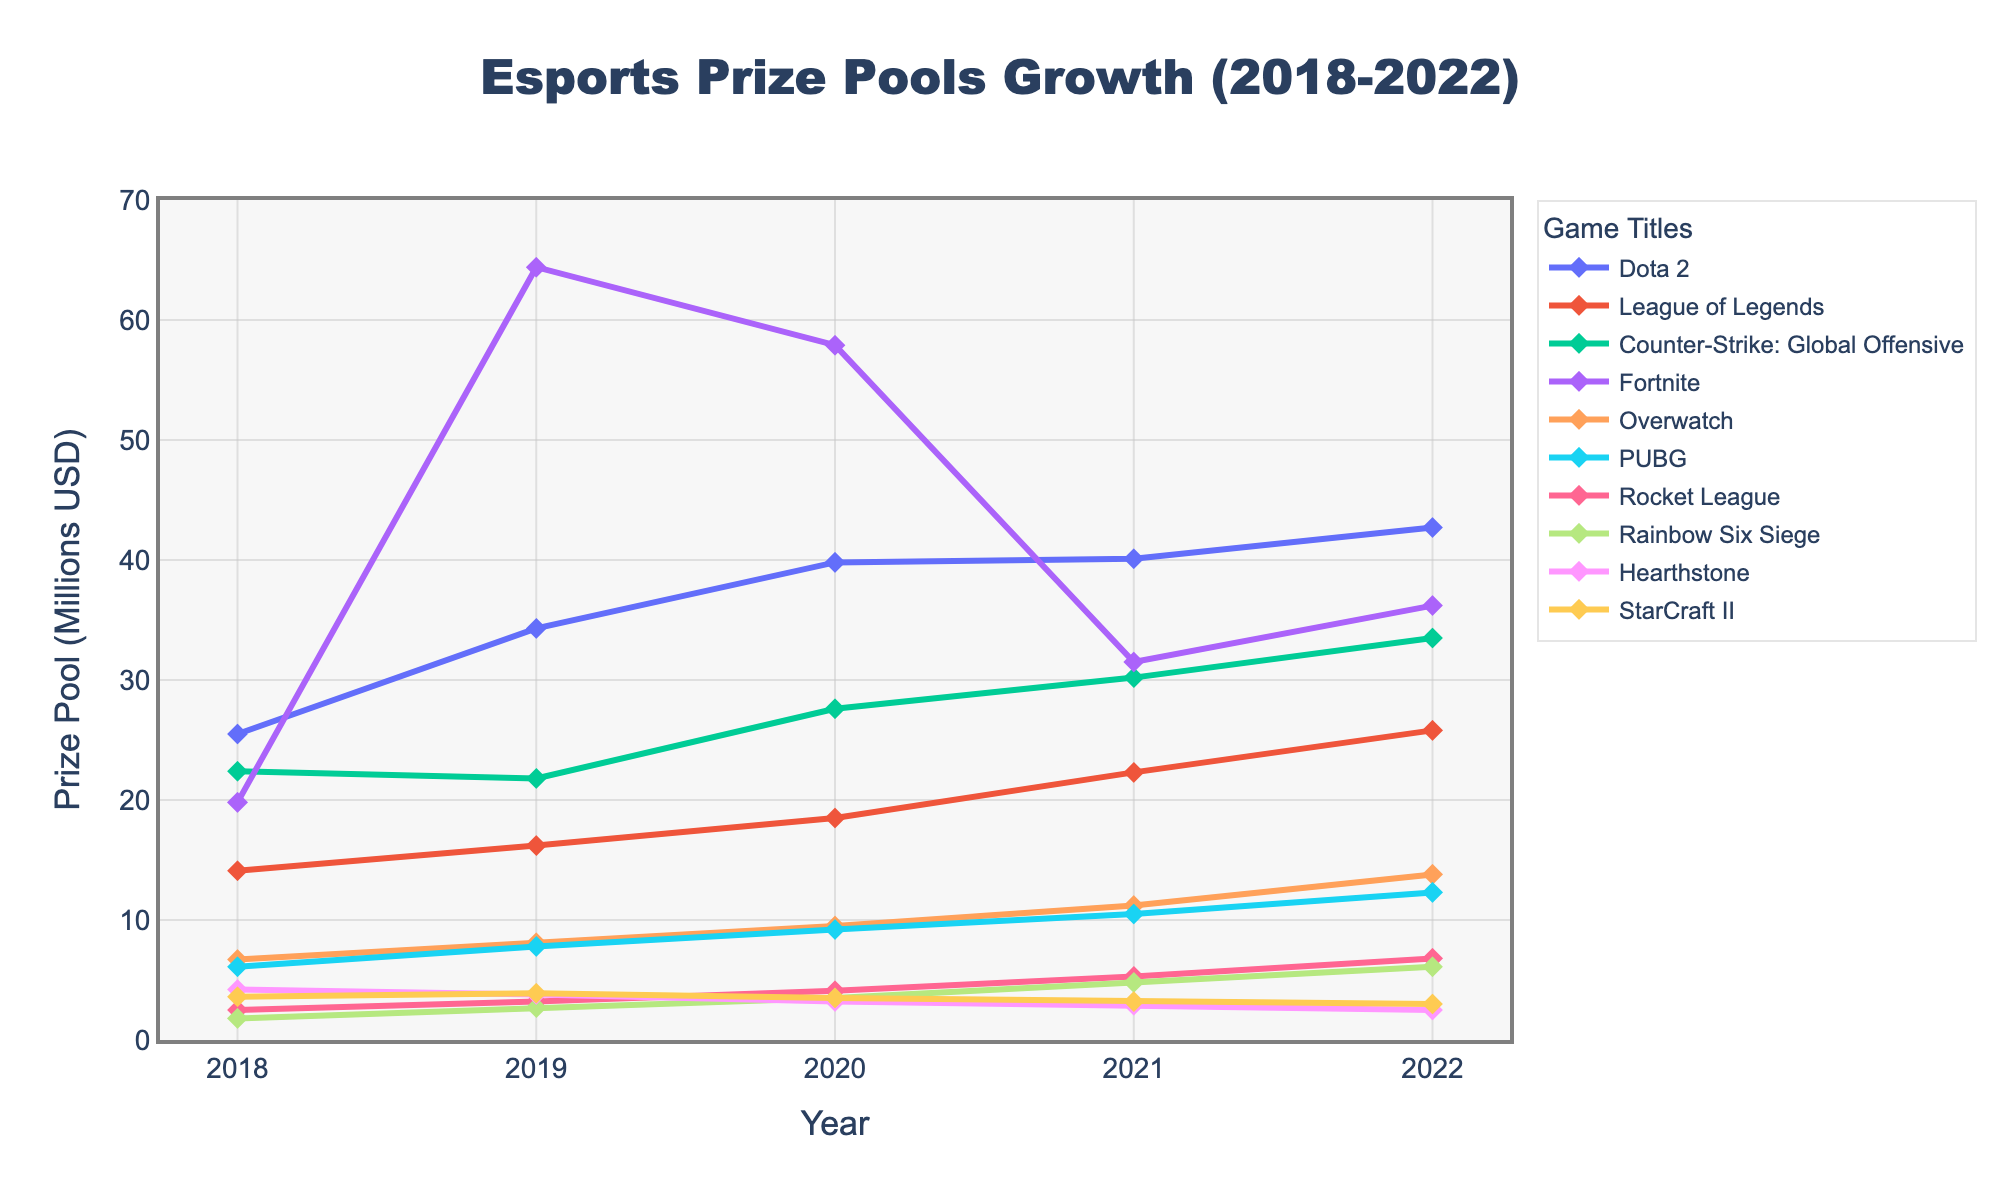Which game title had the highest prize pool in 2022? To determine this, look at the lines in the chart for each game title in the year 2022. The highest data point belongs to Fortnite.
Answer: Fortnite Which game had a smaller prize pool increase from 2018 to 2022, Dota 2 or League of Legends? First, calculate the difference for each game. For Dota 2, it's 42.7 - 25.5 = 17.2 million, and for League of Legends, it's 25.8 - 14.1 = 11.7 million. League of Legends had a smaller increase.
Answer: League of Legends How much did the prize pool of Overwatch increase between 2019 and 2021? Subtract the prize pool in 2019 from the prize pool in 2021 for Overwatch: 11.2 - 8.1 = 3.1 million USD.
Answer: 3.1 million USD Among the listed titles, which game showed a decrease in prize pool between any two consecutive years? Look for a downtrend in the lines. Hearthstone shows a decline between consecutive years: 2018 to 2019 (4.2 to 3.8), 2019 to 2020 (3.8 to 3.2), and 2020 to 2021 (3.2 to 2.9).
Answer: Hearthstone What was the average prize pool for Counter-Strike: Global Offensive from 2018 to 2022? Add the prize pools for each year and divide by 5: (22.4 + 21.8 + 27.6 + 30.2 + 33.5) / 5 = 27.1 million USD.
Answer: 27.1 million USD Compare the prize pool growth from 2018 to 2022 for Fortnite and Rainbow Six Siege. Which game had a greater absolute increase? Fortnite's increase: 36.2 - 19.8 = 16.4 million. Rainbow Six Siege's increase: 6.1 - 1.8 = 4.3 million. Fortnite had a greater absolute increase.
Answer: Fortnite Which game had the least prize pool in 2019? Observe the data points for 2019 and identify the smallest one. Rainbow Six Siege had the least prize pool in 2019.
Answer: Rainbow Six Siege Which two games had the closest prize pools in 2020? Compare the 2020 prize pools for all games. Rocket League (4.1) and StarCraft II (3.5) are closest in prize pools.
Answer: Rocket League, StarCraft II What was the total prize pool for PUBG from 2018 to 2022? Sum the prize pools for each year: 6.1 + 7.8 + 9.2 + 10.5 + 12.3 = 45.9 million USD.
Answer: 45.9 million USD 